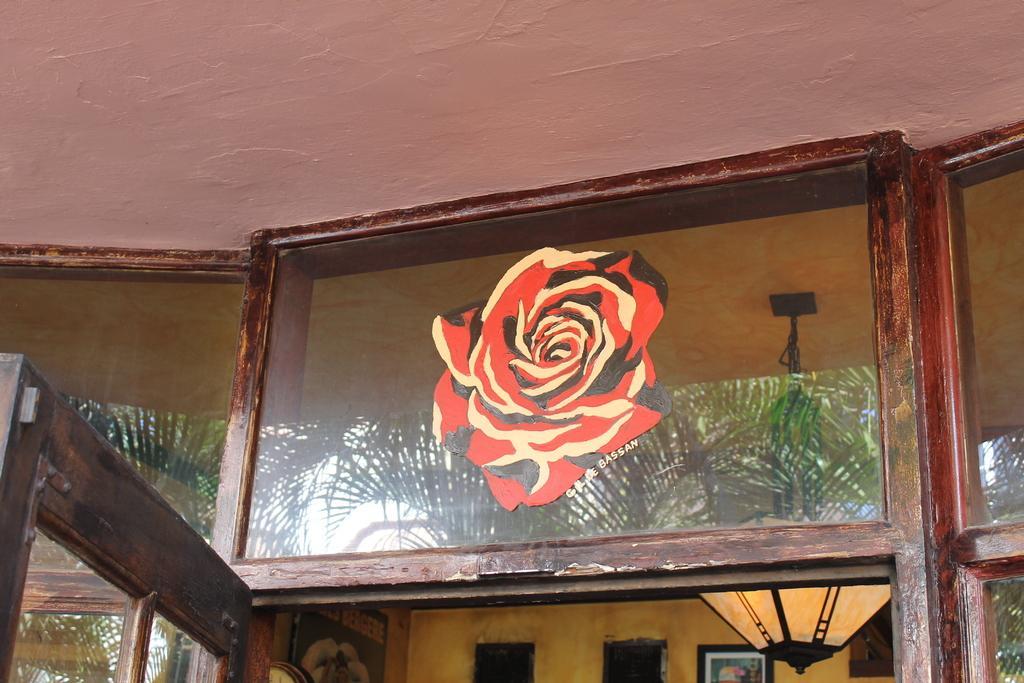Please provide a concise description of this image. In the middle of this image, there is a painting of a rose flower on a glass surface of a building, which is having glass windows and a glass door. In the background, there are photo frames and a light. 